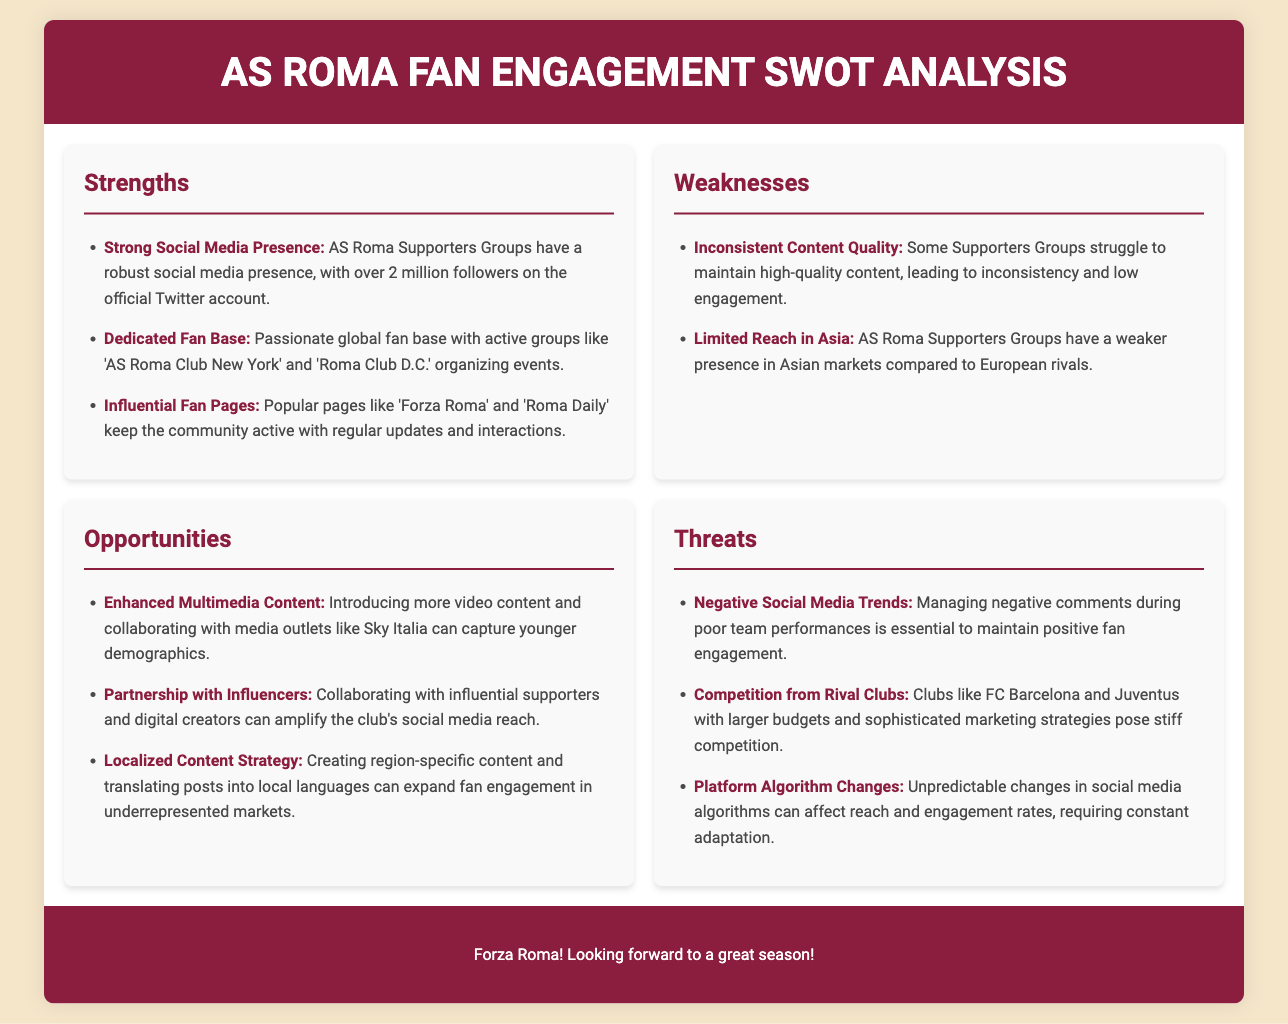what is the total number of followers on the official Twitter account? The total number of followers is a specific data point mentioned under Strengths in the document.
Answer: over 2 million followers which supporter group is mentioned as organizing events in New York? The supporter group is specifically named in the Strengths section, highlighting engagement activities.
Answer: AS Roma Club New York what is one weakness related to content quality? The mention of inconsistent content quality is a notable point in the document under Weaknesses.
Answer: Inconsistent Content Quality name one opportunity for AS Roma's social media strategy. Opportunities for growth are specified under that section, detailing potential strategies for improvement.
Answer: Enhanced Multimedia Content which rival clubs pose competition to AS Roma? This information is found in the Threats section, indicating competitive challenges faced by the supporters.
Answer: FC Barcelona and Juventus how can localized content strategy benefit AS Roma? This requires linking a specific opportunity in the document to its potential impact on fan engagement.
Answer: Expand fan engagement in underrepresented markets what trend must be managed during poor team performances? Negative social media trends are addressed as a concern in the document under Threats.
Answer: Negative Social Media Trends what type of content could help capture younger demographics? This is highlighted as an opportunity that could enhance engagement with a specific age group.
Answer: Video content 